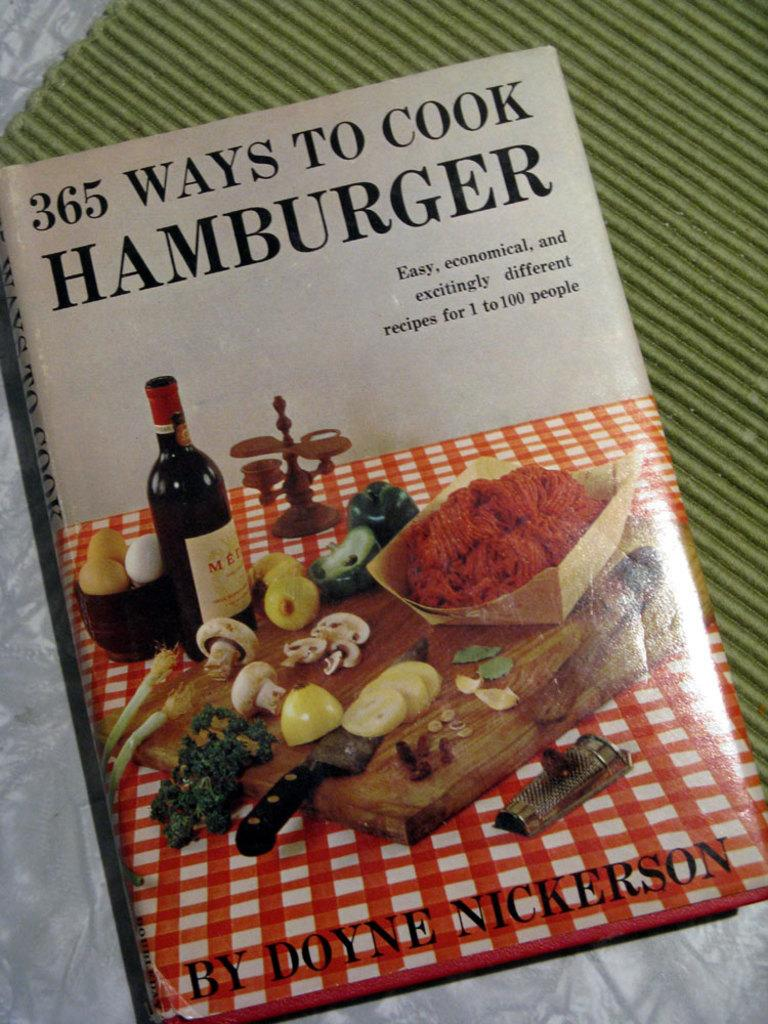Provide a one-sentence caption for the provided image. A cook book that shows how to cook Hamburger. 